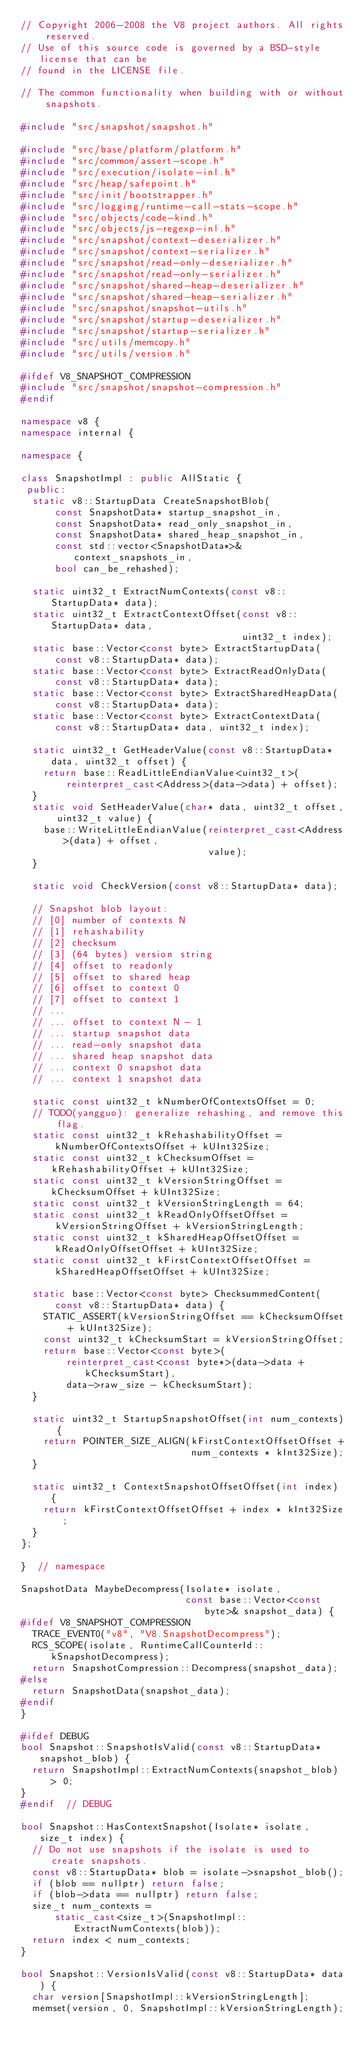Convert code to text. <code><loc_0><loc_0><loc_500><loc_500><_C++_>// Copyright 2006-2008 the V8 project authors. All rights reserved.
// Use of this source code is governed by a BSD-style license that can be
// found in the LICENSE file.

// The common functionality when building with or without snapshots.

#include "src/snapshot/snapshot.h"

#include "src/base/platform/platform.h"
#include "src/common/assert-scope.h"
#include "src/execution/isolate-inl.h"
#include "src/heap/safepoint.h"
#include "src/init/bootstrapper.h"
#include "src/logging/runtime-call-stats-scope.h"
#include "src/objects/code-kind.h"
#include "src/objects/js-regexp-inl.h"
#include "src/snapshot/context-deserializer.h"
#include "src/snapshot/context-serializer.h"
#include "src/snapshot/read-only-deserializer.h"
#include "src/snapshot/read-only-serializer.h"
#include "src/snapshot/shared-heap-deserializer.h"
#include "src/snapshot/shared-heap-serializer.h"
#include "src/snapshot/snapshot-utils.h"
#include "src/snapshot/startup-deserializer.h"
#include "src/snapshot/startup-serializer.h"
#include "src/utils/memcopy.h"
#include "src/utils/version.h"

#ifdef V8_SNAPSHOT_COMPRESSION
#include "src/snapshot/snapshot-compression.h"
#endif

namespace v8 {
namespace internal {

namespace {

class SnapshotImpl : public AllStatic {
 public:
  static v8::StartupData CreateSnapshotBlob(
      const SnapshotData* startup_snapshot_in,
      const SnapshotData* read_only_snapshot_in,
      const SnapshotData* shared_heap_snapshot_in,
      const std::vector<SnapshotData*>& context_snapshots_in,
      bool can_be_rehashed);

  static uint32_t ExtractNumContexts(const v8::StartupData* data);
  static uint32_t ExtractContextOffset(const v8::StartupData* data,
                                       uint32_t index);
  static base::Vector<const byte> ExtractStartupData(
      const v8::StartupData* data);
  static base::Vector<const byte> ExtractReadOnlyData(
      const v8::StartupData* data);
  static base::Vector<const byte> ExtractSharedHeapData(
      const v8::StartupData* data);
  static base::Vector<const byte> ExtractContextData(
      const v8::StartupData* data, uint32_t index);

  static uint32_t GetHeaderValue(const v8::StartupData* data, uint32_t offset) {
    return base::ReadLittleEndianValue<uint32_t>(
        reinterpret_cast<Address>(data->data) + offset);
  }
  static void SetHeaderValue(char* data, uint32_t offset, uint32_t value) {
    base::WriteLittleEndianValue(reinterpret_cast<Address>(data) + offset,
                                 value);
  }

  static void CheckVersion(const v8::StartupData* data);

  // Snapshot blob layout:
  // [0] number of contexts N
  // [1] rehashability
  // [2] checksum
  // [3] (64 bytes) version string
  // [4] offset to readonly
  // [5] offset to shared heap
  // [6] offset to context 0
  // [7] offset to context 1
  // ...
  // ... offset to context N - 1
  // ... startup snapshot data
  // ... read-only snapshot data
  // ... shared heap snapshot data
  // ... context 0 snapshot data
  // ... context 1 snapshot data

  static const uint32_t kNumberOfContextsOffset = 0;
  // TODO(yangguo): generalize rehashing, and remove this flag.
  static const uint32_t kRehashabilityOffset =
      kNumberOfContextsOffset + kUInt32Size;
  static const uint32_t kChecksumOffset = kRehashabilityOffset + kUInt32Size;
  static const uint32_t kVersionStringOffset = kChecksumOffset + kUInt32Size;
  static const uint32_t kVersionStringLength = 64;
  static const uint32_t kReadOnlyOffsetOffset =
      kVersionStringOffset + kVersionStringLength;
  static const uint32_t kSharedHeapOffsetOffset =
      kReadOnlyOffsetOffset + kUInt32Size;
  static const uint32_t kFirstContextOffsetOffset =
      kSharedHeapOffsetOffset + kUInt32Size;

  static base::Vector<const byte> ChecksummedContent(
      const v8::StartupData* data) {
    STATIC_ASSERT(kVersionStringOffset == kChecksumOffset + kUInt32Size);
    const uint32_t kChecksumStart = kVersionStringOffset;
    return base::Vector<const byte>(
        reinterpret_cast<const byte*>(data->data + kChecksumStart),
        data->raw_size - kChecksumStart);
  }

  static uint32_t StartupSnapshotOffset(int num_contexts) {
    return POINTER_SIZE_ALIGN(kFirstContextOffsetOffset +
                              num_contexts * kInt32Size);
  }

  static uint32_t ContextSnapshotOffsetOffset(int index) {
    return kFirstContextOffsetOffset + index * kInt32Size;
  }
};

}  // namespace

SnapshotData MaybeDecompress(Isolate* isolate,
                             const base::Vector<const byte>& snapshot_data) {
#ifdef V8_SNAPSHOT_COMPRESSION
  TRACE_EVENT0("v8", "V8.SnapshotDecompress");
  RCS_SCOPE(isolate, RuntimeCallCounterId::kSnapshotDecompress);
  return SnapshotCompression::Decompress(snapshot_data);
#else
  return SnapshotData(snapshot_data);
#endif
}

#ifdef DEBUG
bool Snapshot::SnapshotIsValid(const v8::StartupData* snapshot_blob) {
  return SnapshotImpl::ExtractNumContexts(snapshot_blob) > 0;
}
#endif  // DEBUG

bool Snapshot::HasContextSnapshot(Isolate* isolate, size_t index) {
  // Do not use snapshots if the isolate is used to create snapshots.
  const v8::StartupData* blob = isolate->snapshot_blob();
  if (blob == nullptr) return false;
  if (blob->data == nullptr) return false;
  size_t num_contexts =
      static_cast<size_t>(SnapshotImpl::ExtractNumContexts(blob));
  return index < num_contexts;
}

bool Snapshot::VersionIsValid(const v8::StartupData* data) {
  char version[SnapshotImpl::kVersionStringLength];
  memset(version, 0, SnapshotImpl::kVersionStringLength);</code> 